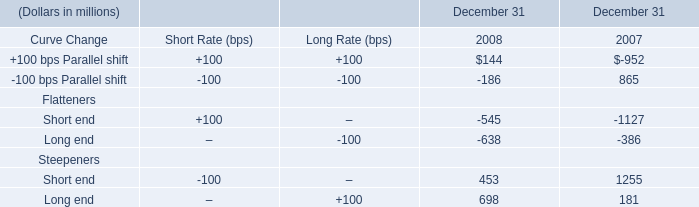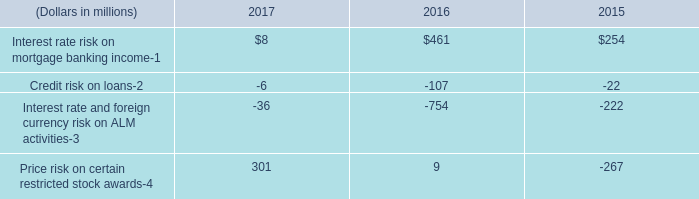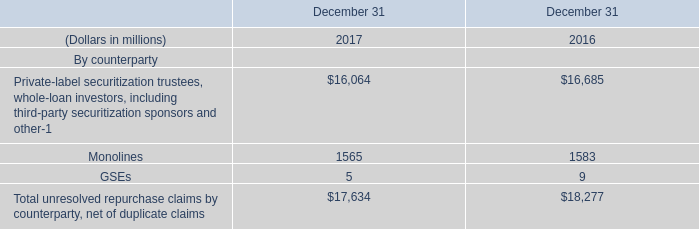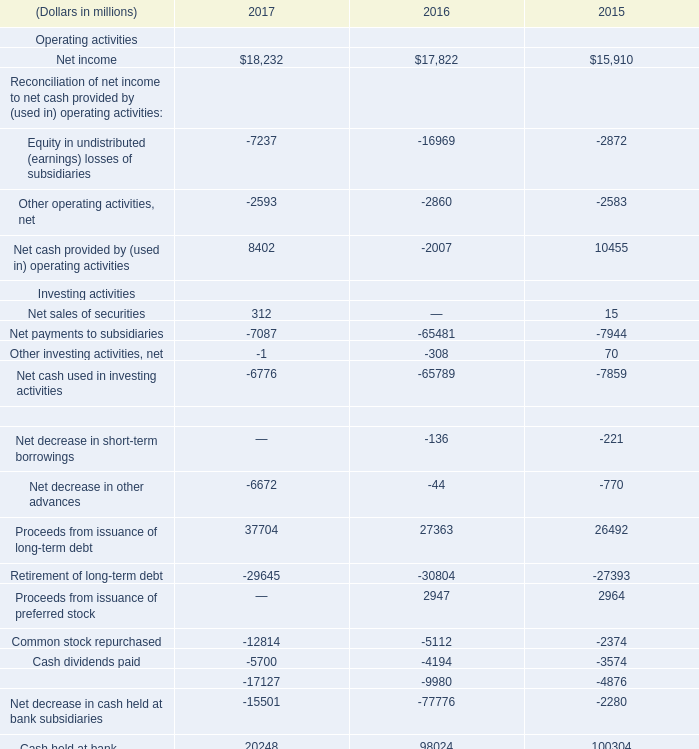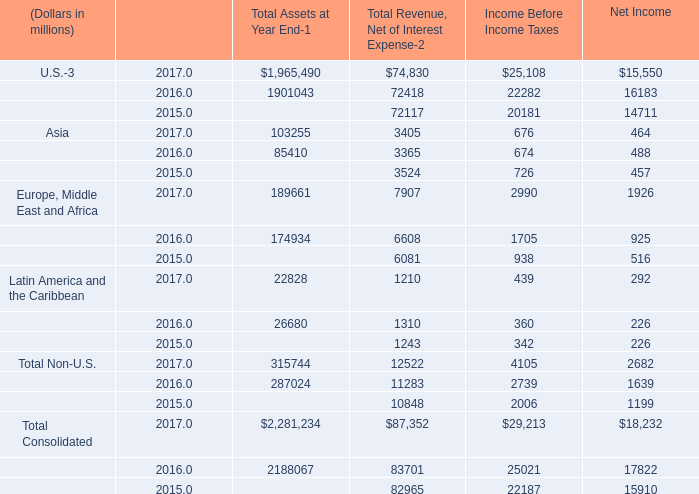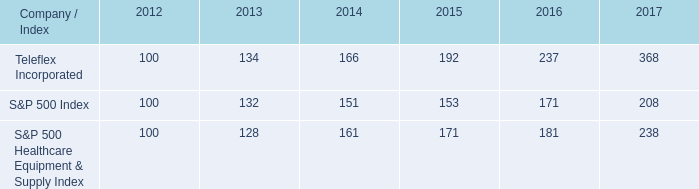In the year with largest amount of Net cash provided by (used in) operating activities, what's the sum of Net cash provided by (used in) operating activities? (in million) 
Answer: 8402. 